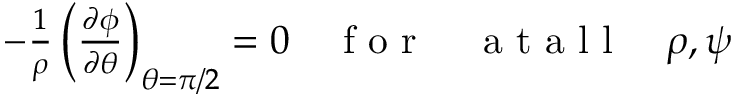Convert formula to latex. <formula><loc_0><loc_0><loc_500><loc_500>\begin{array} { r } { - \frac { 1 } { \rho } \left ( \frac { \partial \phi } { \partial \theta } \right ) _ { \theta = \pi / 2 } = 0 \quad f o r \quad a t a l l \quad \rho , \psi } \end{array}</formula> 